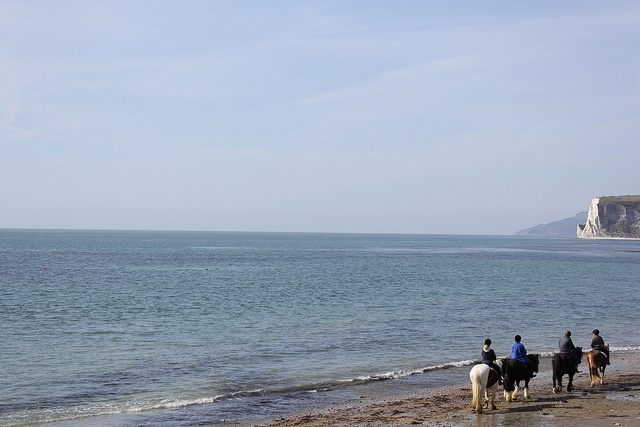Describe the objects in this image and their specific colors. I can see horse in lavender, black, gray, lightgray, and maroon tones, horse in lavender, black, gray, and darkgray tones, horse in lavender, black, gray, and maroon tones, horse in lavender, black, maroon, and gray tones, and people in lavender, black, gray, and darkgray tones in this image. 